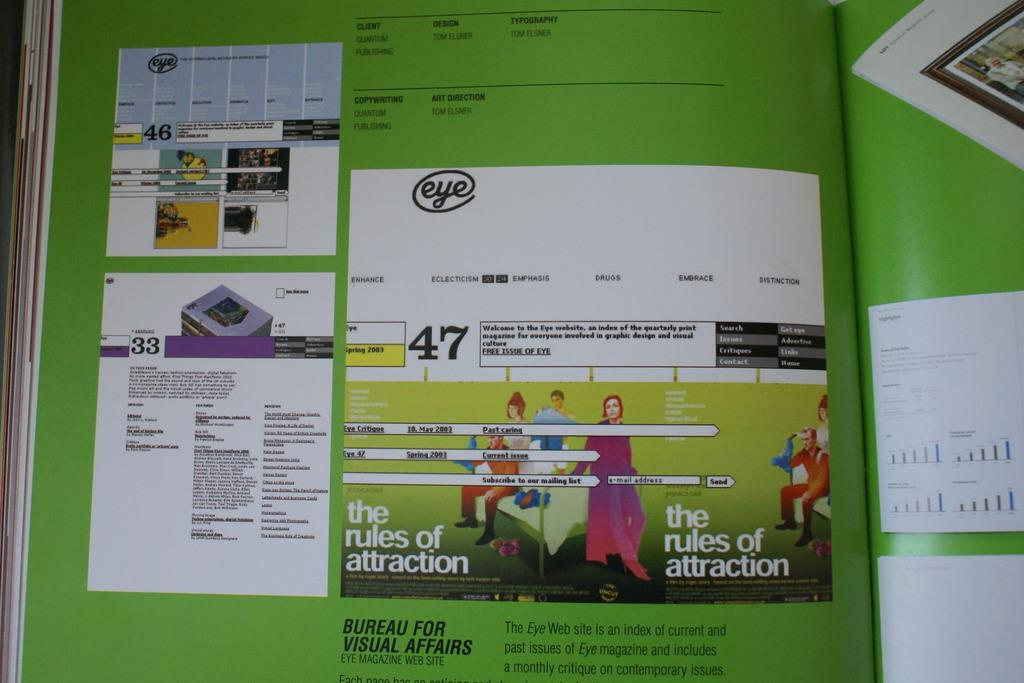<image>
Provide a brief description of the given image. A page of a book showing a graphic explaining the rules of attraction. 